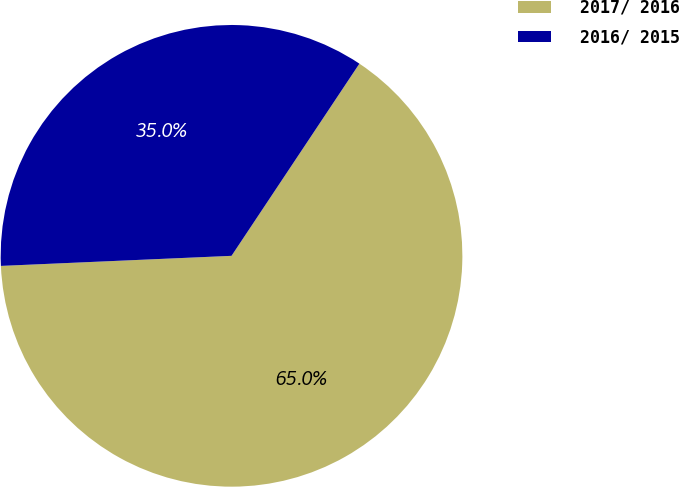Convert chart to OTSL. <chart><loc_0><loc_0><loc_500><loc_500><pie_chart><fcel>2017/ 2016<fcel>2016/ 2015<nl><fcel>64.96%<fcel>35.04%<nl></chart> 